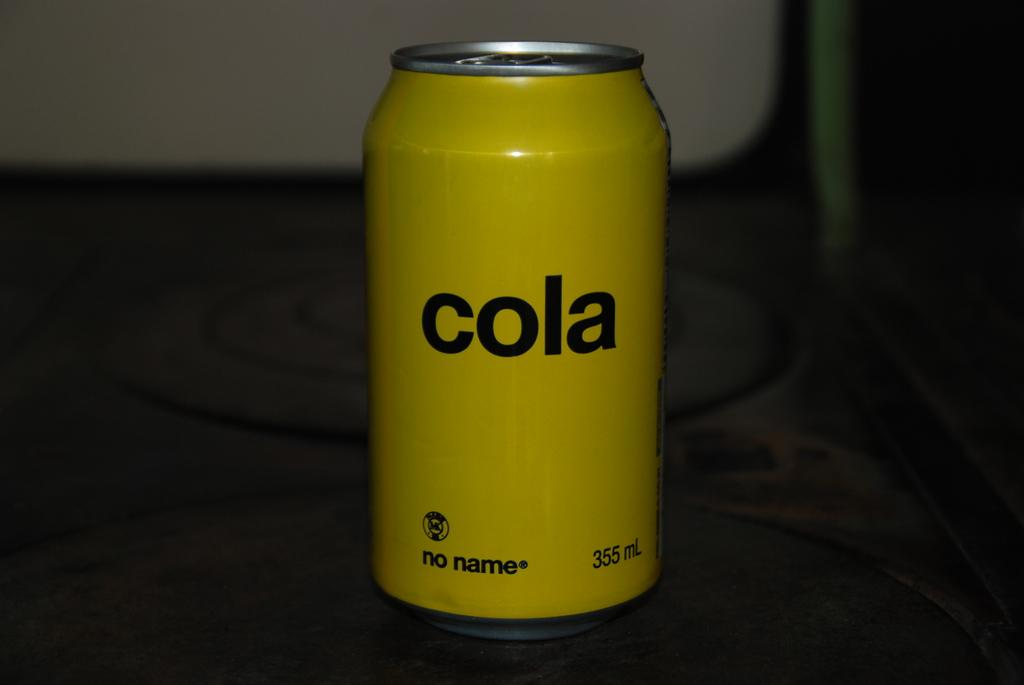<image>
Give a short and clear explanation of the subsequent image. A yellow can from the brand no name says Cola on it. 